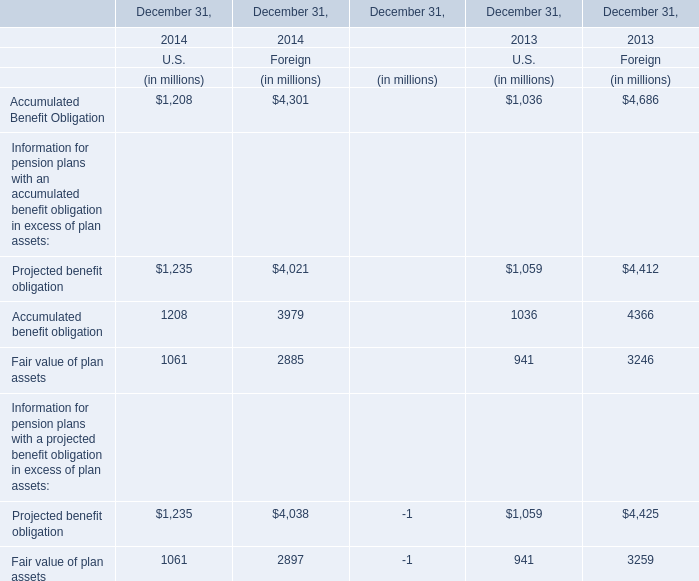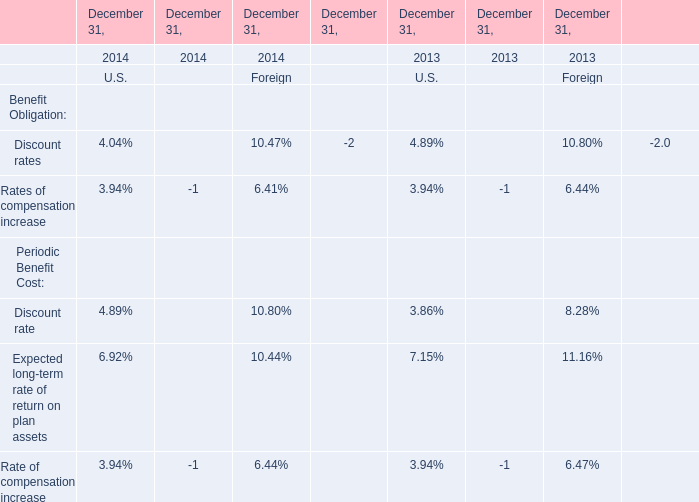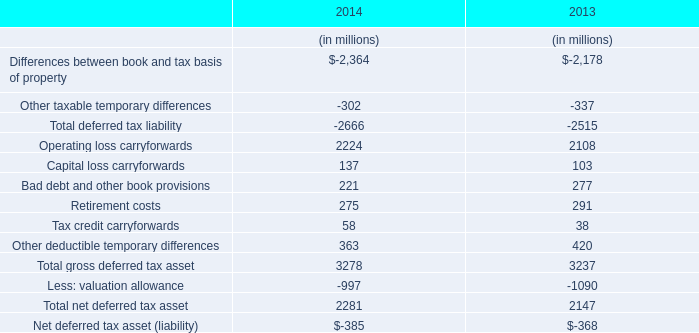In the year with largest amount of U.S. Accumulated Benefit Obligation, what's the sum of U.S. Accumulated Benefit Obligation? (in millions) 
Computations: (1208 + 4301)
Answer: 5509.0. 